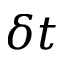<formula> <loc_0><loc_0><loc_500><loc_500>\delta t</formula> 